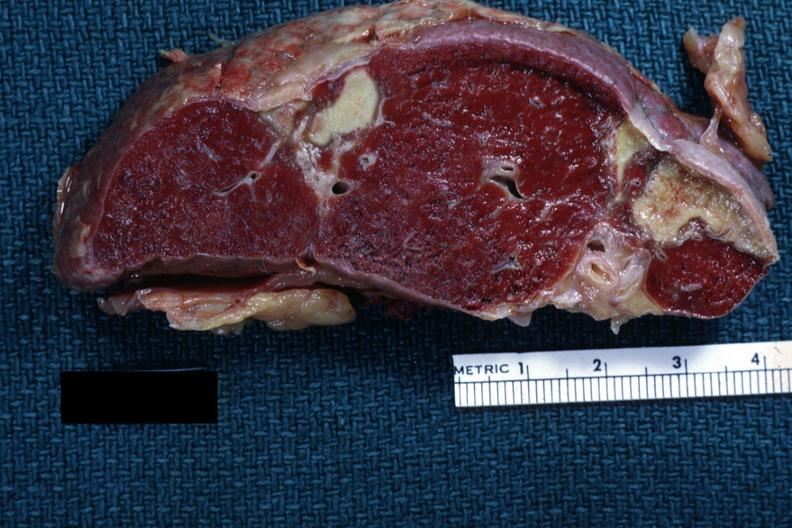s lymphoma present?
Answer the question using a single word or phrase. No 